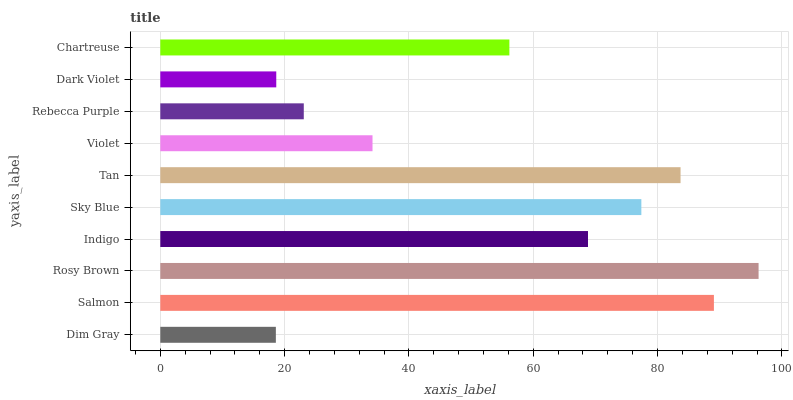Is Dim Gray the minimum?
Answer yes or no. Yes. Is Rosy Brown the maximum?
Answer yes or no. Yes. Is Salmon the minimum?
Answer yes or no. No. Is Salmon the maximum?
Answer yes or no. No. Is Salmon greater than Dim Gray?
Answer yes or no. Yes. Is Dim Gray less than Salmon?
Answer yes or no. Yes. Is Dim Gray greater than Salmon?
Answer yes or no. No. Is Salmon less than Dim Gray?
Answer yes or no. No. Is Indigo the high median?
Answer yes or no. Yes. Is Chartreuse the low median?
Answer yes or no. Yes. Is Dim Gray the high median?
Answer yes or no. No. Is Rebecca Purple the low median?
Answer yes or no. No. 